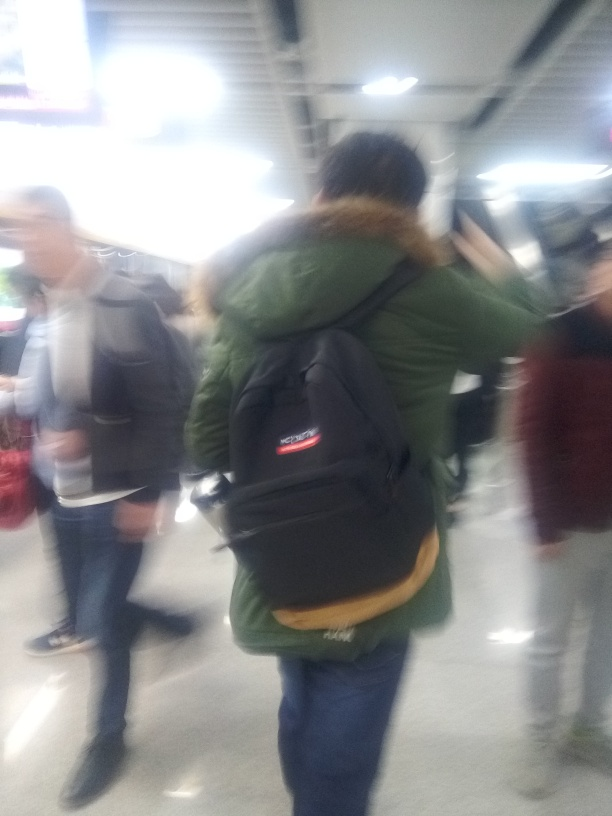Can you describe the setting or the atmosphere in the image? Despite the low quality, the image appears to depict an indoor environment with artificial lighting, possibly a crowded transit station or a public space, given the presence of multiple individuals and the sense of movement. There's a dynamic quality to the scene, reflecting the bustle typically found in such communal areas. 